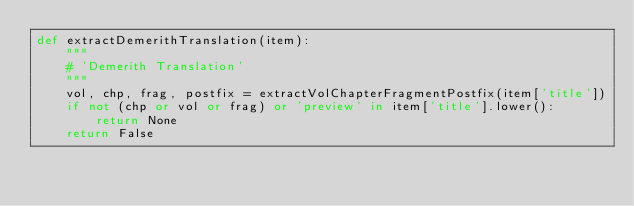<code> <loc_0><loc_0><loc_500><loc_500><_Python_>def extractDemerithTranslation(item):
	"""
	# 'Demerith Translation'
	"""
	vol, chp, frag, postfix = extractVolChapterFragmentPostfix(item['title'])
	if not (chp or vol or frag) or 'preview' in item['title'].lower():
		return None
	return False
</code> 